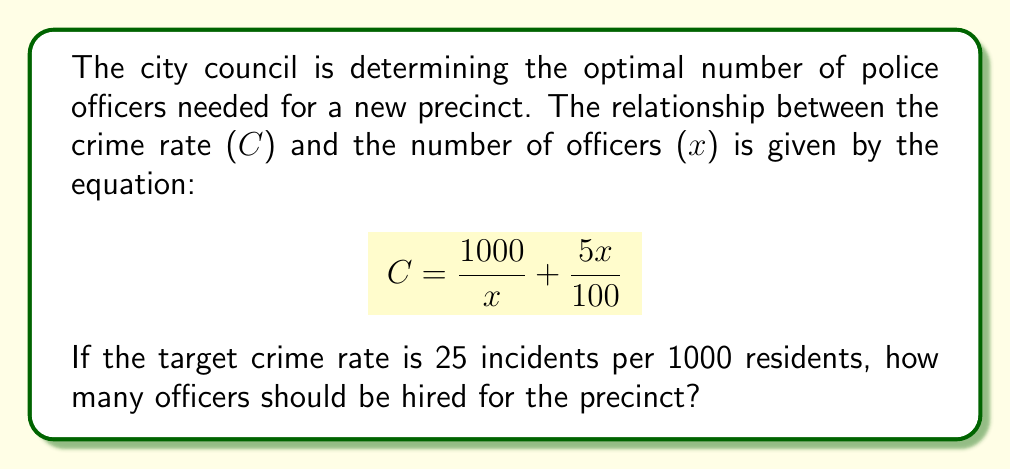Can you solve this math problem? 1) We start with the given equation:
   $$C = \frac{1000}{x} + \frac{5x}{100}$$

2) We know that the target crime rate (C) is 25, so we substitute this:
   $$25 = \frac{1000}{x} + \frac{5x}{100}$$

3) To solve this rational equation, first multiply both sides by 100x to clear the denominators:
   $$2500x = 100000 + 5x^2$$

4) Rearrange the equation to standard quadratic form:
   $$5x^2 - 2500x + 100000 = 0$$

5) This is a quadratic equation. We can solve it using the quadratic formula:
   $$x = \frac{-b \pm \sqrt{b^2 - 4ac}}{2a}$$
   where $a=5$, $b=-2500$, and $c=100000$

6) Substituting these values:
   $$x = \frac{2500 \pm \sqrt{(-2500)^2 - 4(5)(100000)}}{2(5)}$$

7) Simplify:
   $$x = \frac{2500 \pm \sqrt{6250000 - 2000000}}{10}$$
   $$x = \frac{2500 \pm \sqrt{4250000}}{10}$$
   $$x = \frac{2500 \pm 2061.55}{10}$$

8) This gives us two solutions:
   $$x = 456.155$$ or $$x = 43.845$$

9) Since we can't have a fractional number of officers, and we need a positive number, we round up to the nearest whole number: 457.
Answer: 457 officers 